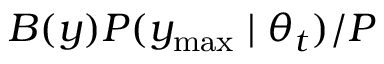Convert formula to latex. <formula><loc_0><loc_0><loc_500><loc_500>B ( y ) P ( y _ { \max } | \theta _ { t } ) / P</formula> 